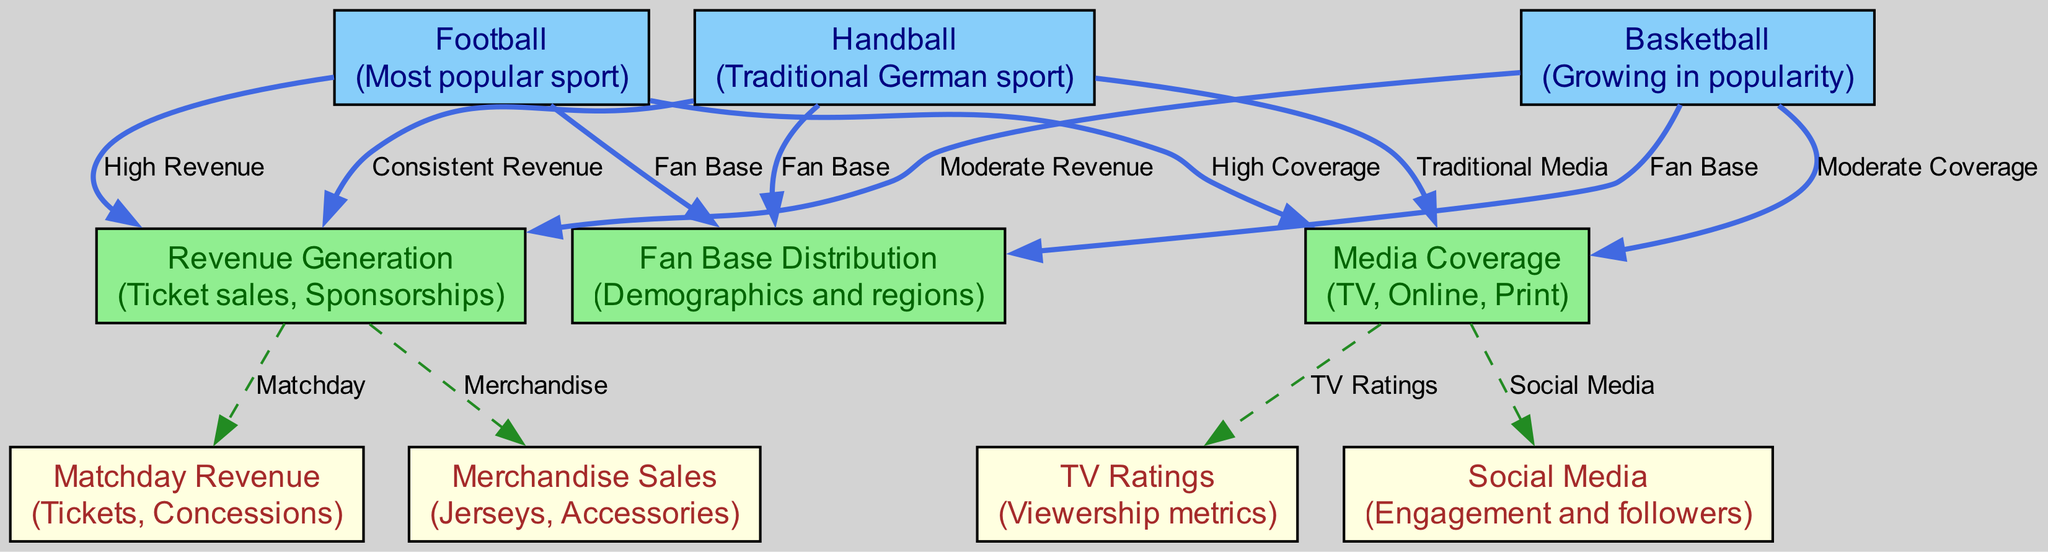What sport is considered the most popular in Germany? The diagram identifies "Football" as the most popular sport in Germany, as specifically stated in the description associated with the node.
Answer: Football Which sport has a fan base distribution listed? The diagram shows that all three sports—Football, Basketball, and Handball—have connections to the node "Fan Base Distribution," indicating their respective fan base demographics.
Answer: Football, Basketball, Handball How many nodes represent sports in the diagram? The diagram includes three nodes that specifically represent sports: Football, Basketball, and Handball, which can be directly counted from the node list.
Answer: 3 What type of media coverage does Football have? According to the node connections, Football has a "High Coverage" in media, as indicated by the edge connecting Football to the Media Coverage node with that label.
Answer: High Coverage Which sport has moderate revenue generation? The diagram associates Basketball with "Moderate Revenue" through the edge connecting it to the Revenue Generation node, indicating its financial status compared to other sports.
Answer: Basketball What is the relationship between Media Coverage and TV Ratings? The connection from the Media Coverage node to the TV Ratings node indicates that Media Coverage directly influences or is associated with the TV Ratings, as shown by the edge labeled "TV Ratings."
Answer: TV Ratings What generates revenue on matchdays? The diagram indicates that "Matchday Revenue" is part of the revenue generation for Football, Basketball, and Handball, as each of these sports is connected to the "Matchday" node through edges.
Answer: Tickets, Concessions How does Handball's media coverage differ from that of Football? Handball's media coverage is categorized as "Traditional Media," while Football has "High Coverage." This difference is shown through their respective connections to the Media Coverage node, clearly labeling the nature of coverage for each sport.
Answer: Traditional Media vs. High Coverage Which sport is noted for consistent revenue? The diagram positions Handball with the label "Consistent Revenue" within its connection to the Revenue Generation node, indicating that this sport reliably generates revenue.
Answer: Handball What merchandise is associated with Revenue Generation? The Revenue Generation node has edges connecting to "Matchday Revenue" and "Merchandise Sales," showing that merchandise is a key component of revenue generation in sports.
Answer: Jerseys, Accessories 